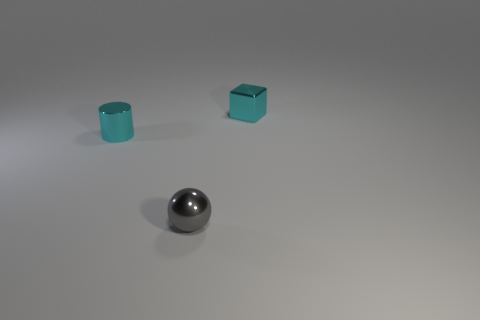Add 2 big blue shiny cylinders. How many objects exist? 5 Add 1 tiny cyan cubes. How many tiny cyan cubes exist? 2 Subtract 0 red balls. How many objects are left? 3 Subtract all cylinders. How many objects are left? 2 Subtract all tiny metallic balls. Subtract all large blue metal balls. How many objects are left? 2 Add 1 tiny cyan things. How many tiny cyan things are left? 3 